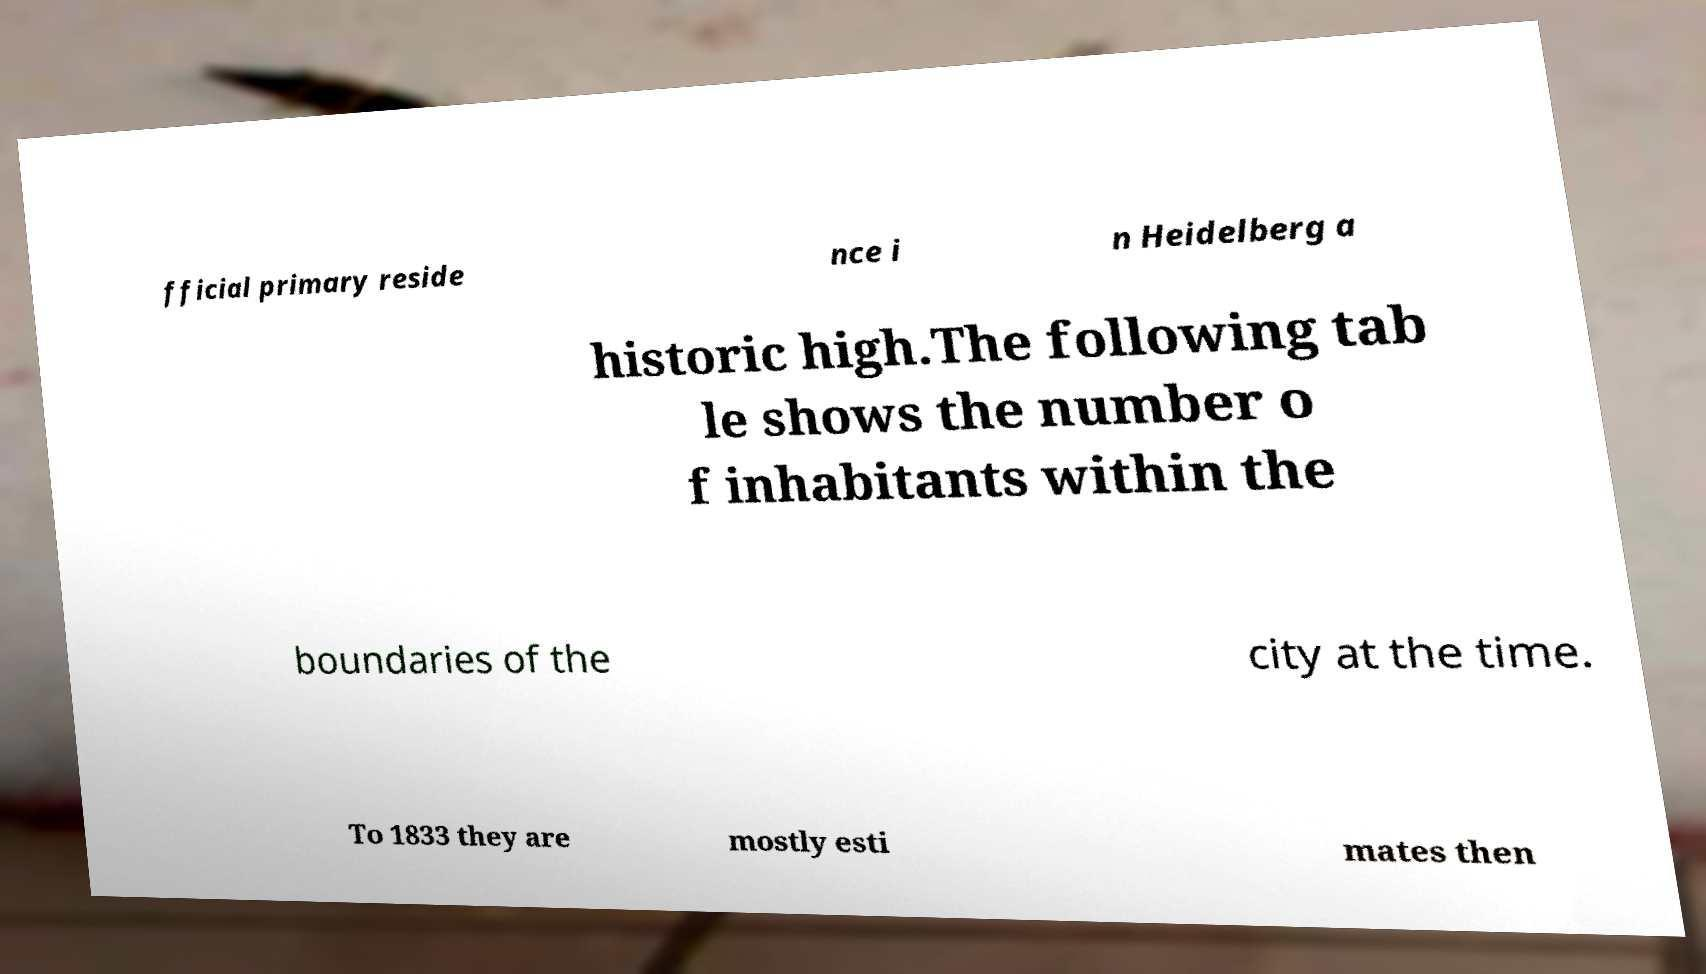What messages or text are displayed in this image? I need them in a readable, typed format. fficial primary reside nce i n Heidelberg a historic high.The following tab le shows the number o f inhabitants within the boundaries of the city at the time. To 1833 they are mostly esti mates then 